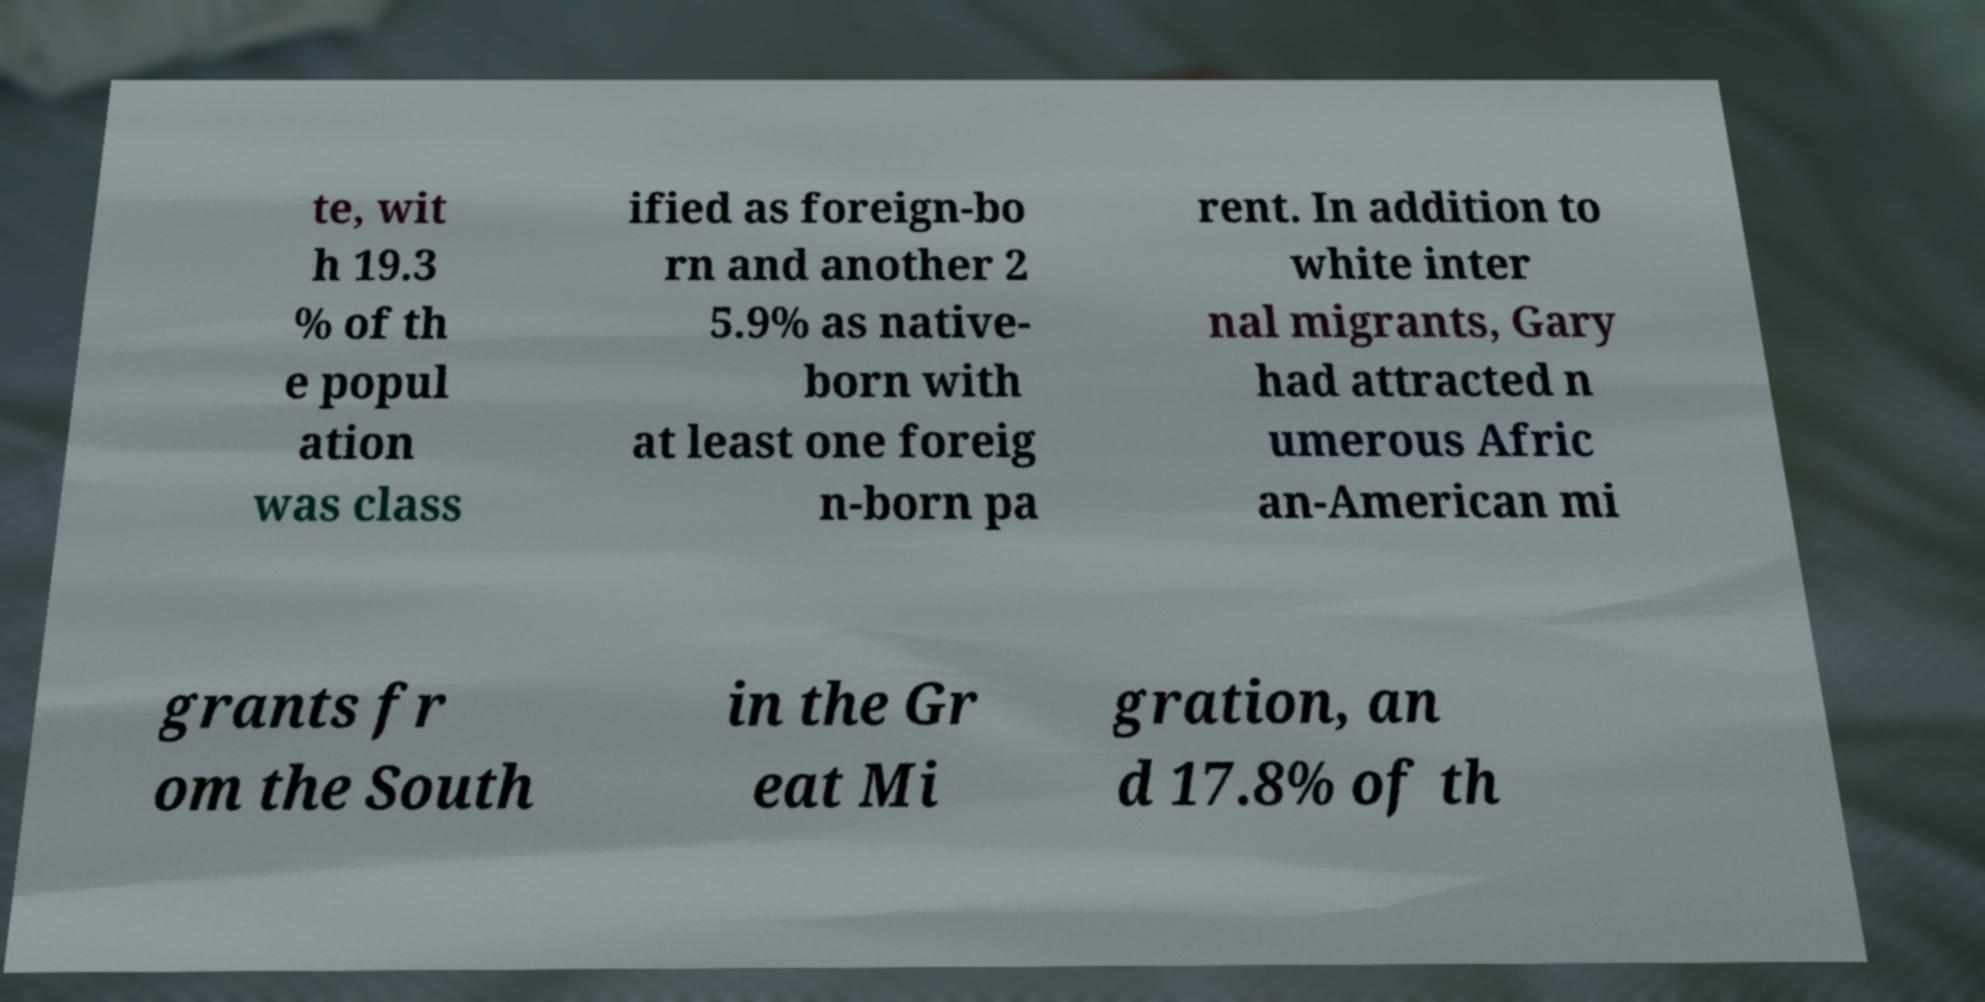Could you assist in decoding the text presented in this image and type it out clearly? te, wit h 19.3 % of th e popul ation was class ified as foreign-bo rn and another 2 5.9% as native- born with at least one foreig n-born pa rent. In addition to white inter nal migrants, Gary had attracted n umerous Afric an-American mi grants fr om the South in the Gr eat Mi gration, an d 17.8% of th 